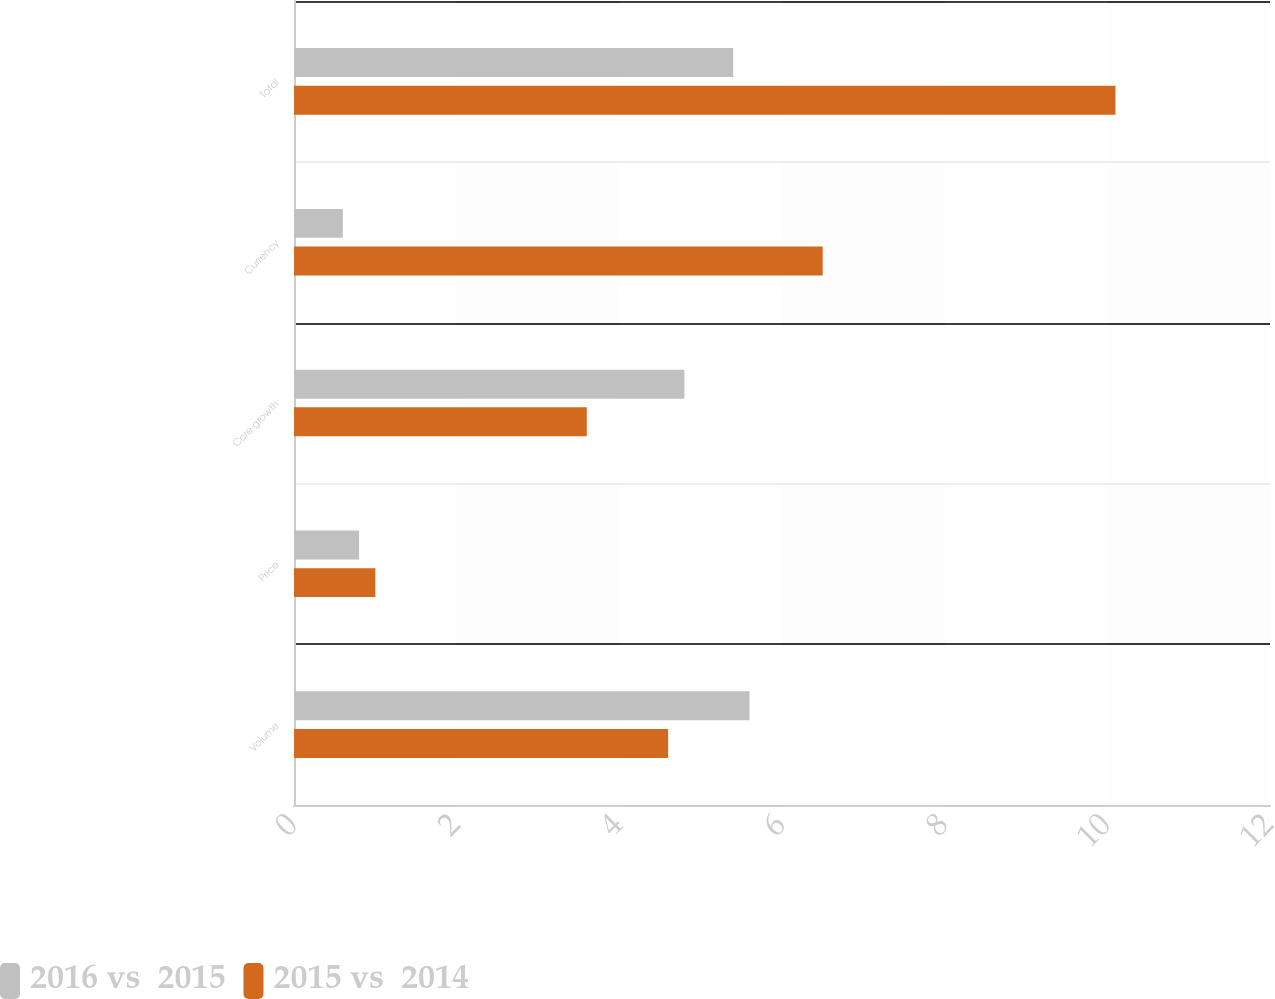<chart> <loc_0><loc_0><loc_500><loc_500><stacked_bar_chart><ecel><fcel>Volume<fcel>Price<fcel>Core growth<fcel>Currency<fcel>Total<nl><fcel>2016 vs  2015<fcel>5.6<fcel>0.8<fcel>4.8<fcel>0.6<fcel>5.4<nl><fcel>2015 vs  2014<fcel>4.6<fcel>1<fcel>3.6<fcel>6.5<fcel>10.1<nl></chart> 